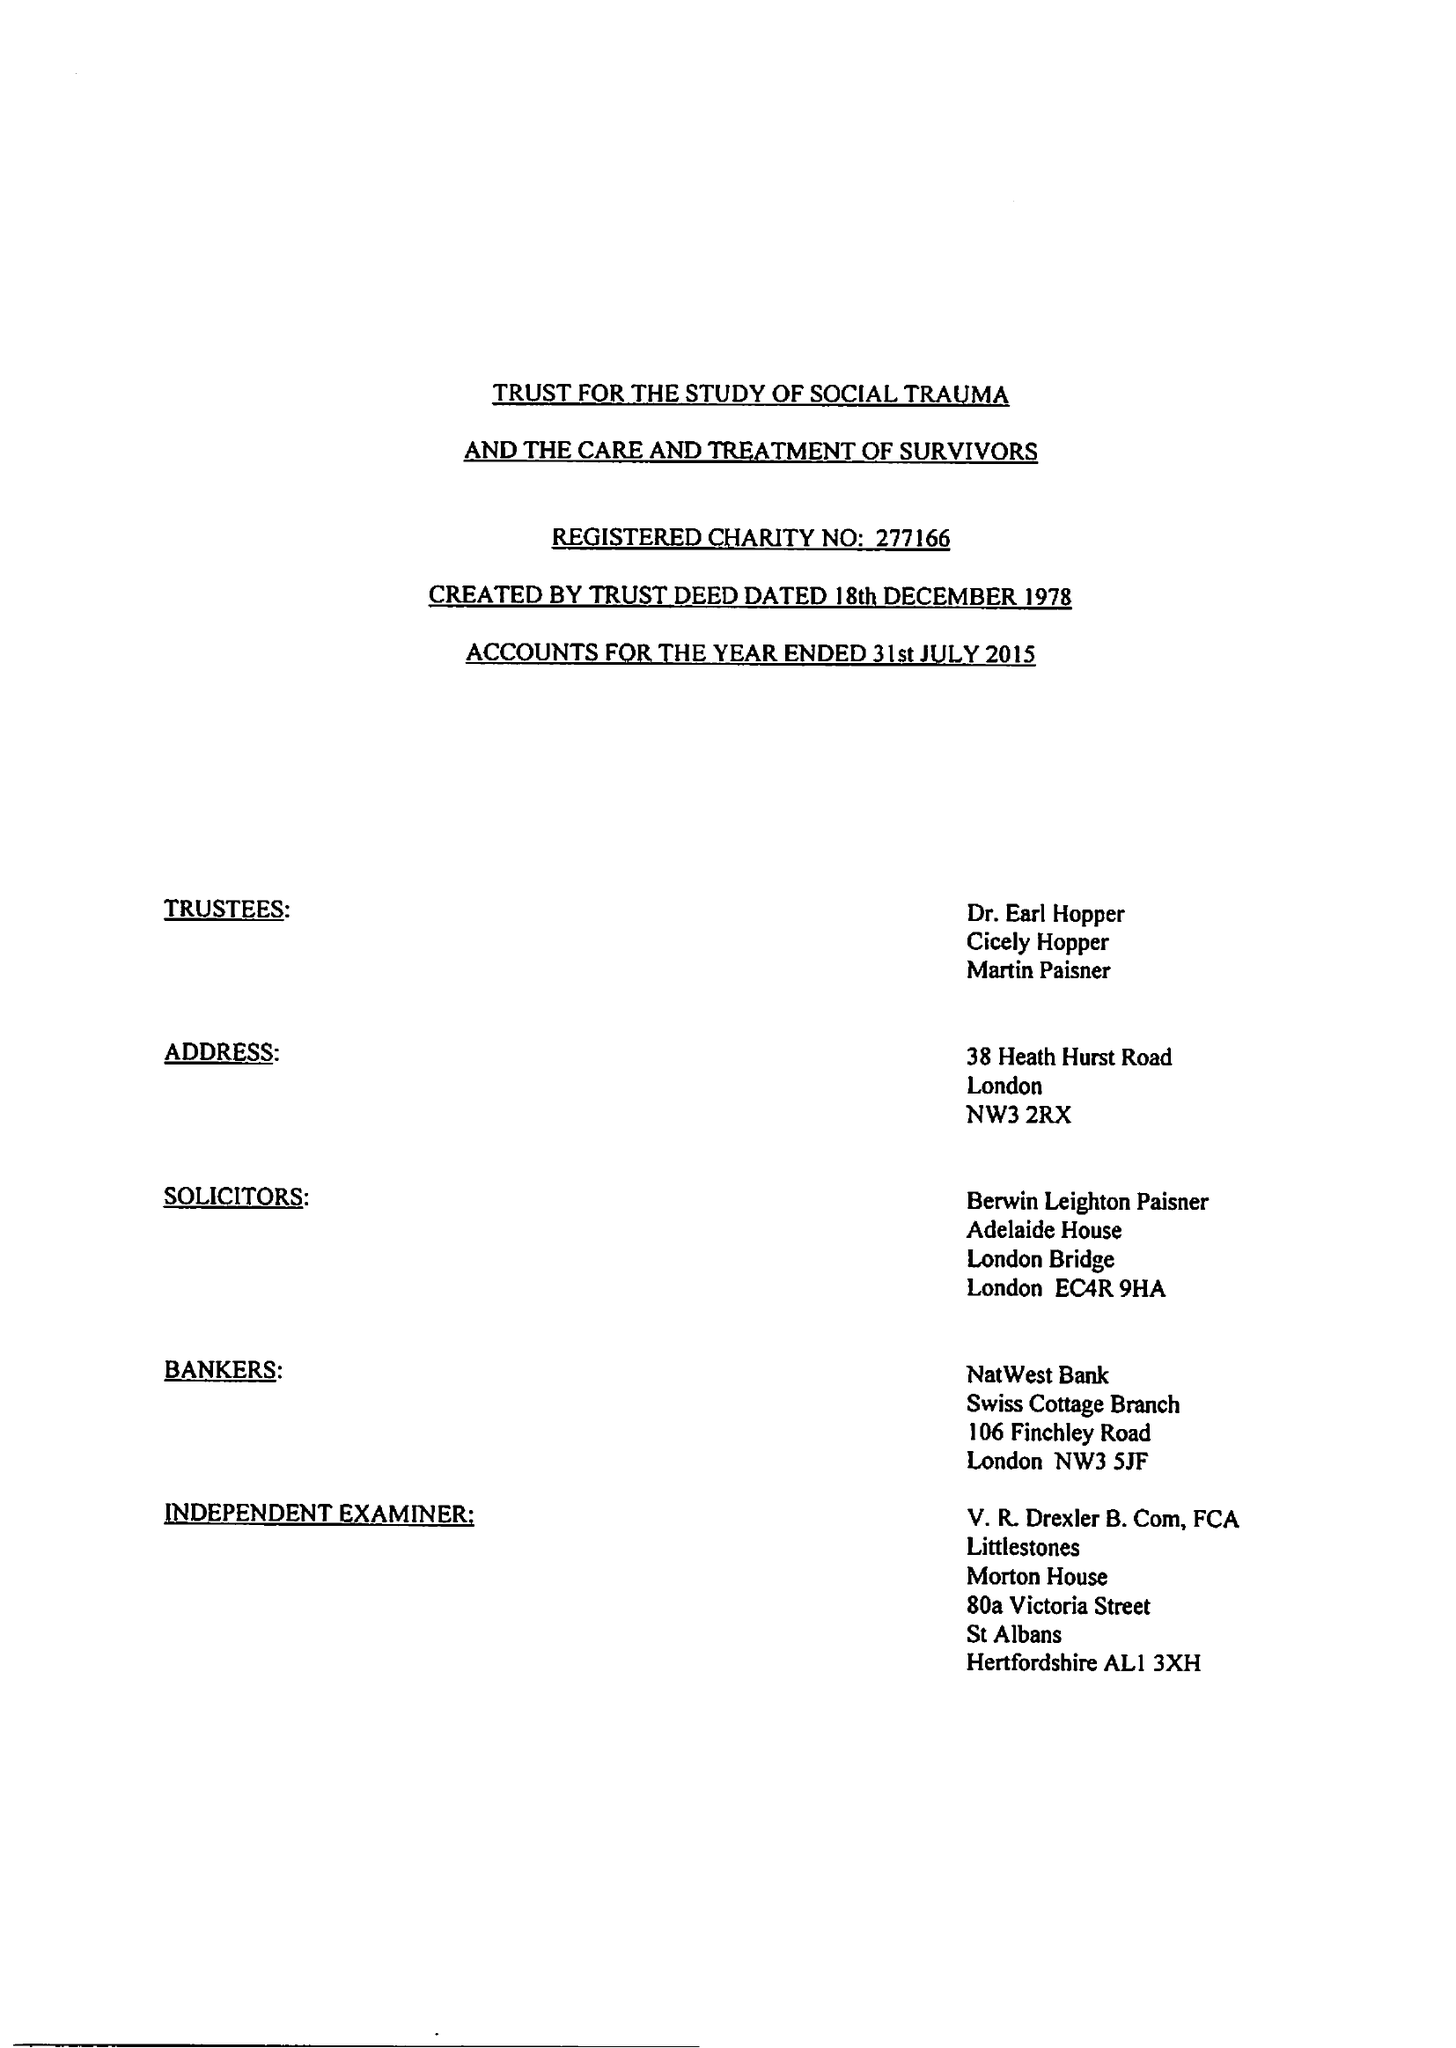What is the value for the spending_annually_in_british_pounds?
Answer the question using a single word or phrase. 76649.00 